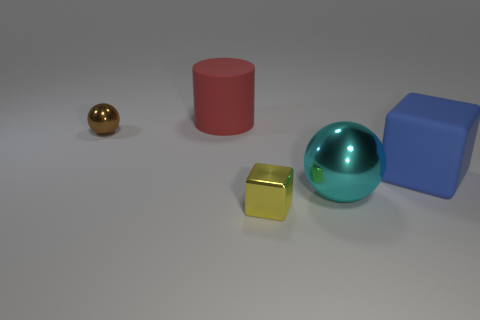Are there any cyan shiny spheres that have the same size as the red matte object?
Offer a terse response. Yes. What color is the tiny thing that is the same shape as the large shiny object?
Provide a succinct answer. Brown. There is a shiny ball that is to the left of the cyan metal sphere; are there any large shiny objects on the right side of it?
Your answer should be very brief. Yes. There is a small shiny thing that is left of the big red cylinder; is its shape the same as the cyan object?
Provide a succinct answer. Yes. What shape is the blue object?
Keep it short and to the point. Cube. What number of brown objects have the same material as the cyan ball?
Offer a terse response. 1. There is a matte cube; does it have the same color as the matte object that is left of the big blue thing?
Offer a terse response. No. What number of large gray metallic objects are there?
Provide a short and direct response. 0. Is there another large sphere that has the same color as the big metal ball?
Offer a very short reply. No. What is the color of the metallic sphere behind the metal sphere that is in front of the ball behind the cyan thing?
Ensure brevity in your answer.  Brown. 